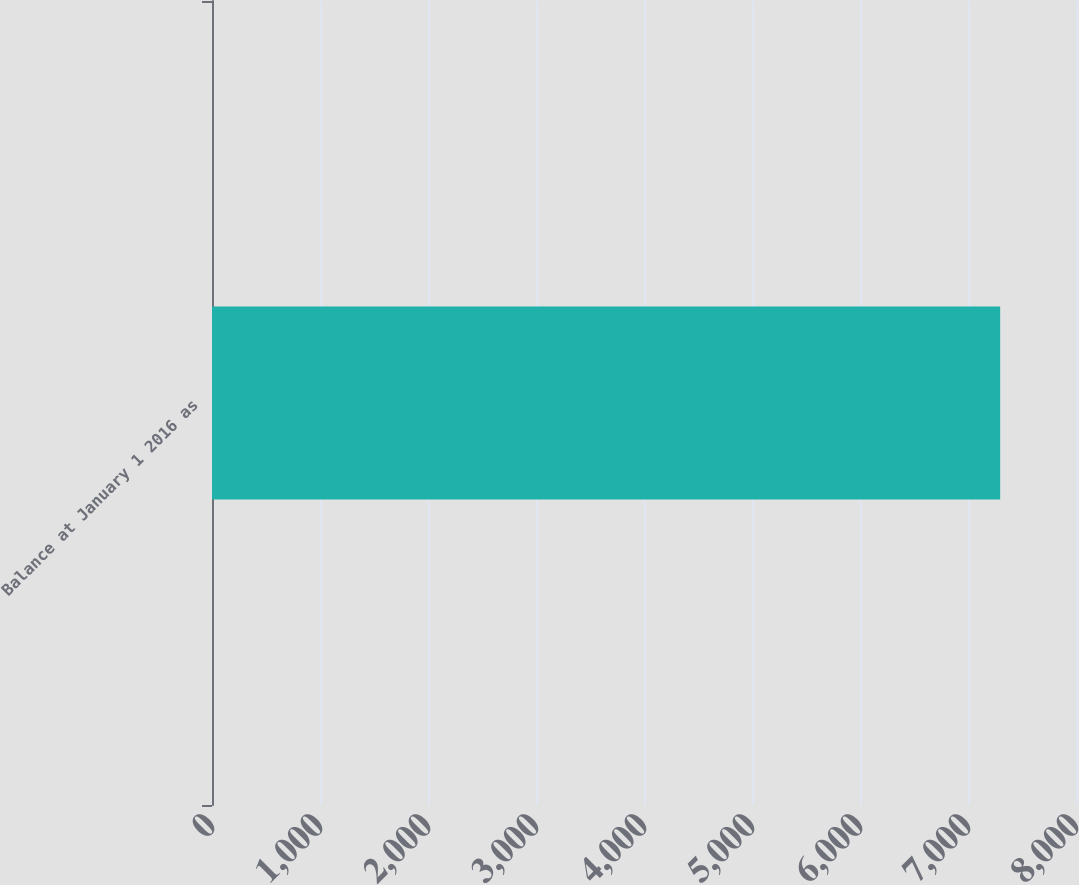<chart> <loc_0><loc_0><loc_500><loc_500><bar_chart><fcel>Balance at January 1 2016 as<nl><fcel>7298<nl></chart> 